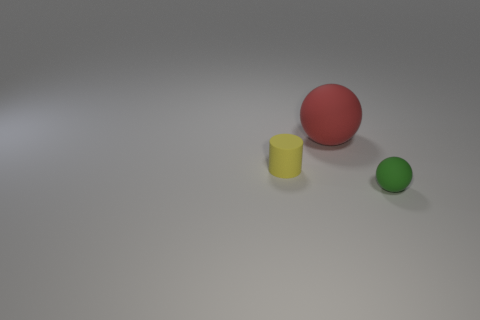Subtract all green balls. How many balls are left? 1 Subtract 1 balls. How many balls are left? 1 Add 2 large red matte spheres. How many objects exist? 5 Subtract all balls. How many objects are left? 1 Add 3 small cylinders. How many small cylinders are left? 4 Add 2 large matte objects. How many large matte objects exist? 3 Subtract 1 yellow cylinders. How many objects are left? 2 Subtract all cyan cylinders. Subtract all red balls. How many cylinders are left? 1 Subtract all green metal balls. Subtract all small green matte objects. How many objects are left? 2 